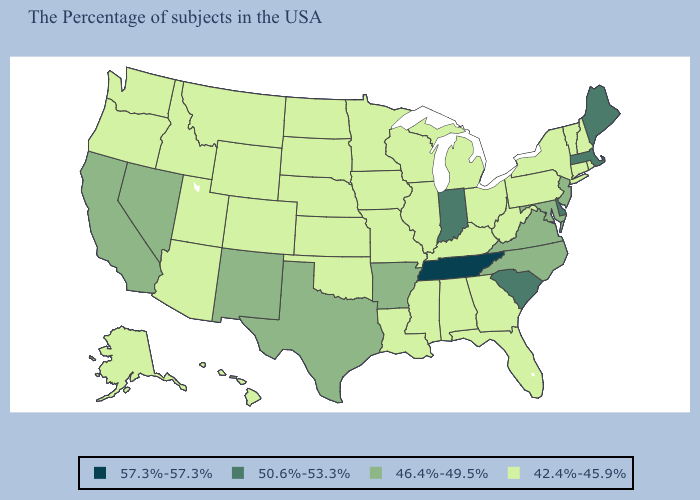Does Wyoming have the highest value in the USA?
Quick response, please. No. Does Colorado have the lowest value in the West?
Concise answer only. Yes. Does Missouri have the same value as Arkansas?
Quick response, please. No. Name the states that have a value in the range 50.6%-53.3%?
Give a very brief answer. Maine, Massachusetts, Delaware, South Carolina, Indiana. Among the states that border Rhode Island , does Massachusetts have the lowest value?
Give a very brief answer. No. Name the states that have a value in the range 57.3%-57.3%?
Give a very brief answer. Tennessee. What is the highest value in states that border Connecticut?
Answer briefly. 50.6%-53.3%. What is the highest value in the South ?
Give a very brief answer. 57.3%-57.3%. Among the states that border New Hampshire , does Vermont have the highest value?
Concise answer only. No. Name the states that have a value in the range 46.4%-49.5%?
Concise answer only. New Jersey, Maryland, Virginia, North Carolina, Arkansas, Texas, New Mexico, Nevada, California. Among the states that border Arizona , which have the highest value?
Short answer required. New Mexico, Nevada, California. Which states have the lowest value in the USA?
Concise answer only. Rhode Island, New Hampshire, Vermont, Connecticut, New York, Pennsylvania, West Virginia, Ohio, Florida, Georgia, Michigan, Kentucky, Alabama, Wisconsin, Illinois, Mississippi, Louisiana, Missouri, Minnesota, Iowa, Kansas, Nebraska, Oklahoma, South Dakota, North Dakota, Wyoming, Colorado, Utah, Montana, Arizona, Idaho, Washington, Oregon, Alaska, Hawaii. Name the states that have a value in the range 46.4%-49.5%?
Be succinct. New Jersey, Maryland, Virginia, North Carolina, Arkansas, Texas, New Mexico, Nevada, California. What is the value of Wyoming?
Concise answer only. 42.4%-45.9%. 